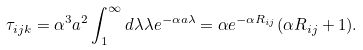<formula> <loc_0><loc_0><loc_500><loc_500>\tau _ { i j k } = \alpha ^ { 3 } a ^ { 2 } \int _ { 1 } ^ { \infty } d \lambda \lambda e ^ { - \alpha a \lambda } = \alpha e ^ { - \alpha R _ { i j } } ( \alpha R _ { i j } + 1 ) .</formula> 